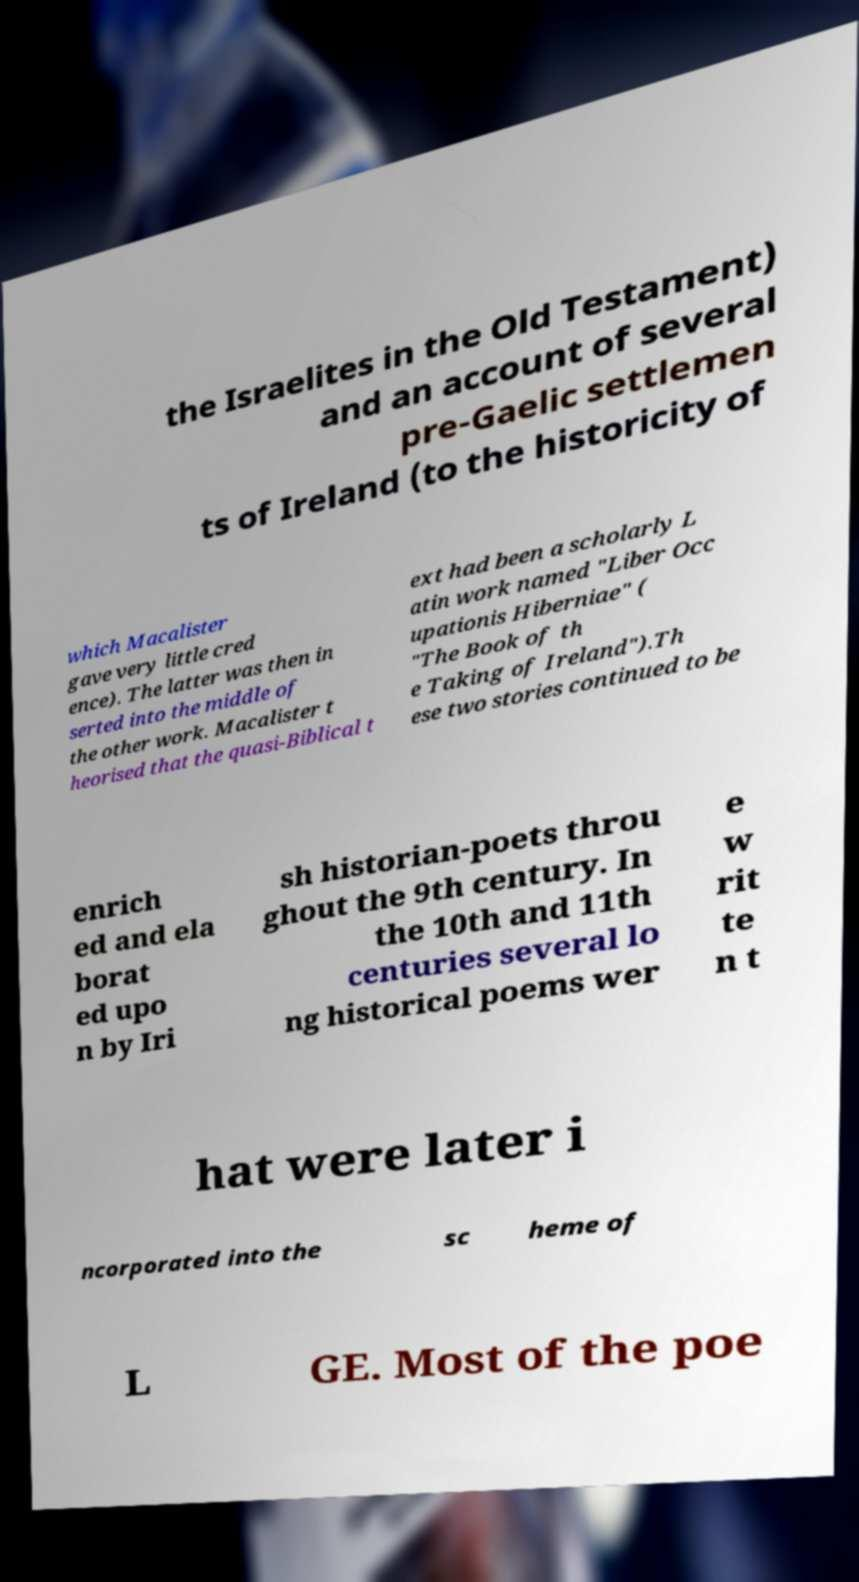For documentation purposes, I need the text within this image transcribed. Could you provide that? the Israelites in the Old Testament) and an account of several pre-Gaelic settlemen ts of Ireland (to the historicity of which Macalister gave very little cred ence). The latter was then in serted into the middle of the other work. Macalister t heorised that the quasi-Biblical t ext had been a scholarly L atin work named "Liber Occ upationis Hiberniae" ( "The Book of th e Taking of Ireland").Th ese two stories continued to be enrich ed and ela borat ed upo n by Iri sh historian-poets throu ghout the 9th century. In the 10th and 11th centuries several lo ng historical poems wer e w rit te n t hat were later i ncorporated into the sc heme of L GE. Most of the poe 